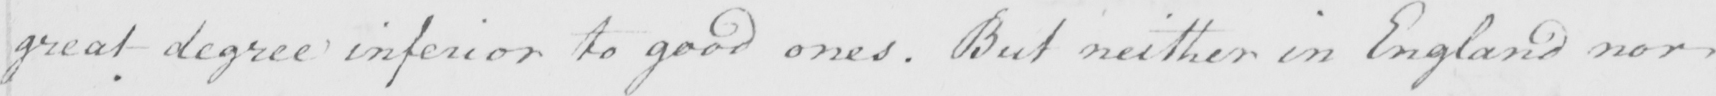Can you tell me what this handwritten text says? great degree inferior to good ones . But neither in England nor 